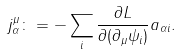<formula> <loc_0><loc_0><loc_500><loc_500>j _ { \alpha } ^ { \mu } \colon = - \sum _ { i } \frac { \partial L } { \partial ( \partial _ { \mu } \psi _ { i } ) } a _ { \alpha i } .</formula> 